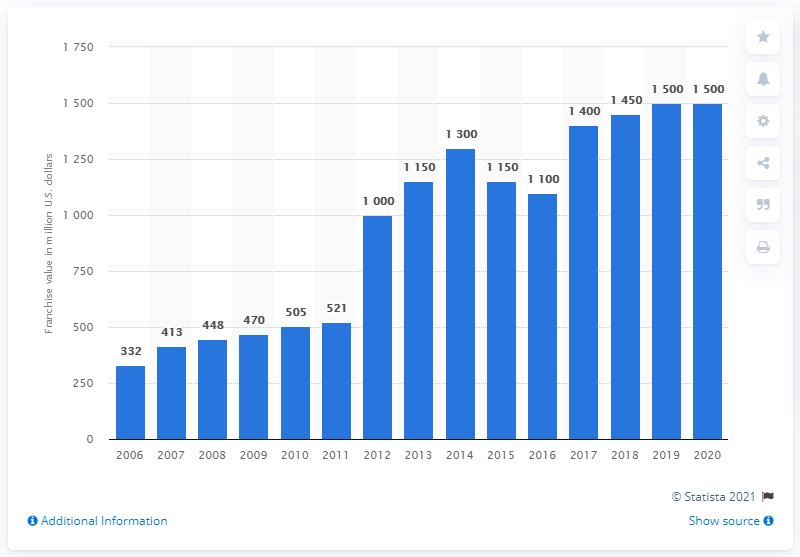Specify some key components in this picture. In 2020, the Maple Leafs franchise had a value of 1,500 dollars. 